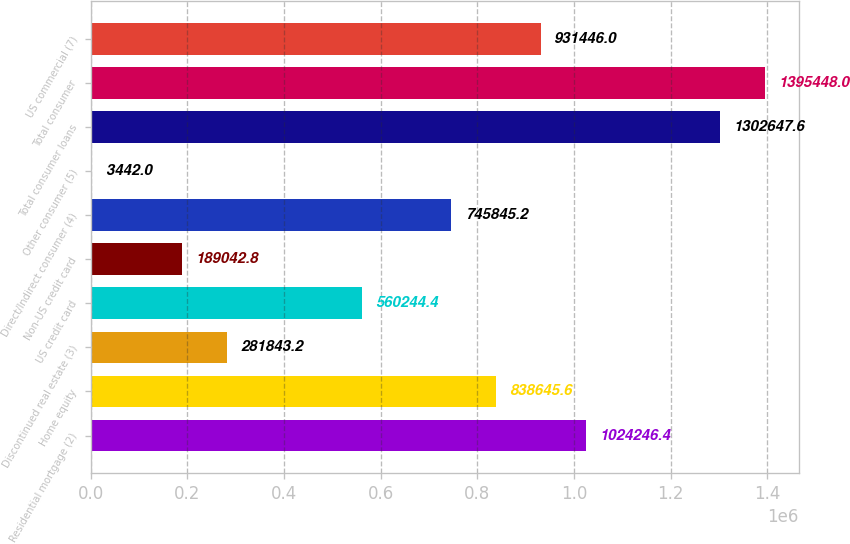<chart> <loc_0><loc_0><loc_500><loc_500><bar_chart><fcel>Residential mortgage (2)<fcel>Home equity<fcel>Discontinued real estate (3)<fcel>US credit card<fcel>Non-US credit card<fcel>Direct/Indirect consumer (4)<fcel>Other consumer (5)<fcel>Total consumer loans<fcel>Total consumer<fcel>US commercial (7)<nl><fcel>1.02425e+06<fcel>838646<fcel>281843<fcel>560244<fcel>189043<fcel>745845<fcel>3442<fcel>1.30265e+06<fcel>1.39545e+06<fcel>931446<nl></chart> 